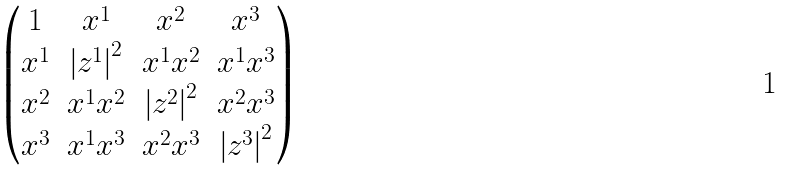<formula> <loc_0><loc_0><loc_500><loc_500>\begin{pmatrix} 1 & x ^ { 1 } & x ^ { 2 } & x ^ { 3 } \\ x ^ { 1 } & { | z ^ { 1 } | } ^ { 2 } & x ^ { 1 } x ^ { 2 } & x ^ { 1 } x ^ { 3 } \\ x ^ { 2 } & x ^ { 1 } x ^ { 2 } & { | z ^ { 2 } | } ^ { 2 } & x ^ { 2 } x ^ { 3 } \\ x ^ { 3 } & x ^ { 1 } x ^ { 3 } & x ^ { 2 } x ^ { 3 } & { | z ^ { 3 } | } ^ { 2 } \end{pmatrix}</formula> 